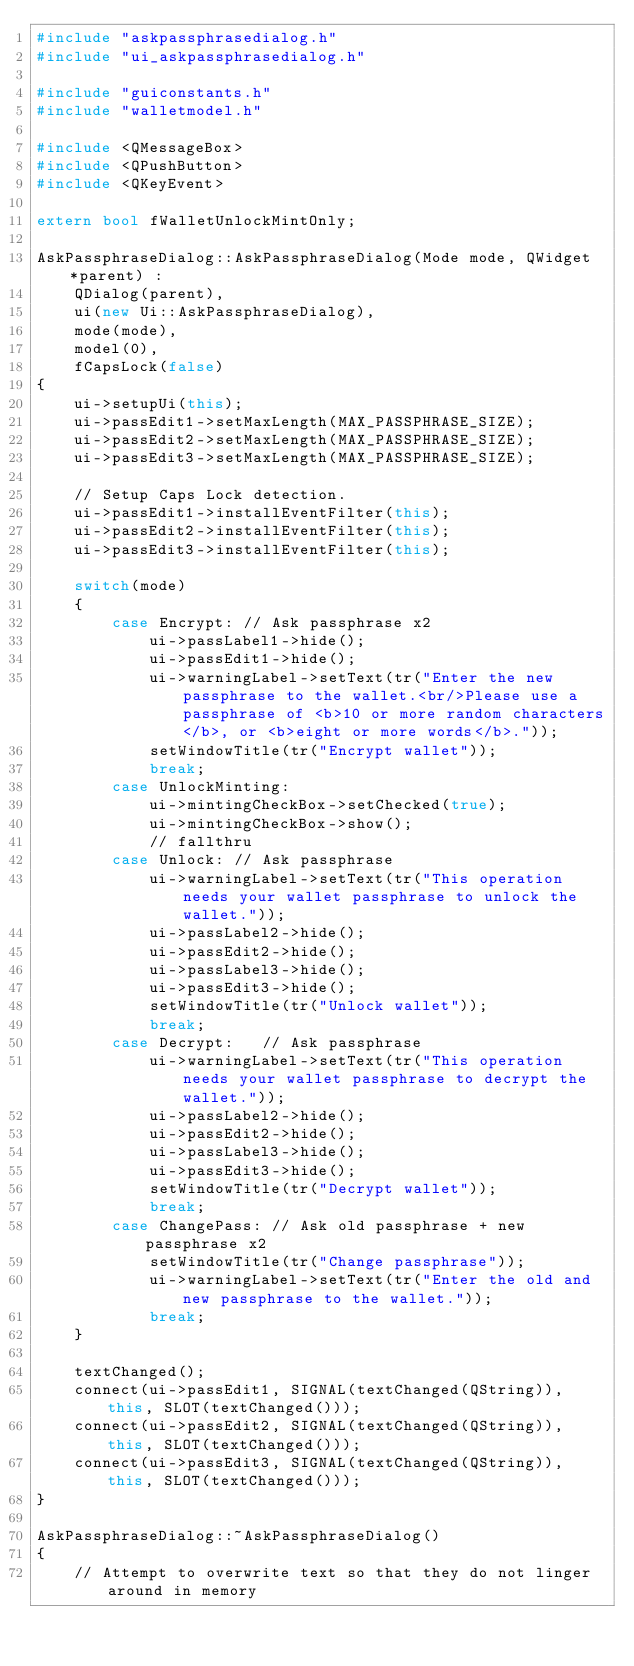Convert code to text. <code><loc_0><loc_0><loc_500><loc_500><_C++_>#include "askpassphrasedialog.h"
#include "ui_askpassphrasedialog.h"

#include "guiconstants.h"
#include "walletmodel.h"

#include <QMessageBox>
#include <QPushButton>
#include <QKeyEvent>

extern bool fWalletUnlockMintOnly;

AskPassphraseDialog::AskPassphraseDialog(Mode mode, QWidget *parent) :
    QDialog(parent),
    ui(new Ui::AskPassphraseDialog),
    mode(mode),
    model(0),
    fCapsLock(false)
{
    ui->setupUi(this);
    ui->passEdit1->setMaxLength(MAX_PASSPHRASE_SIZE);
    ui->passEdit2->setMaxLength(MAX_PASSPHRASE_SIZE);
    ui->passEdit3->setMaxLength(MAX_PASSPHRASE_SIZE);
    
    // Setup Caps Lock detection.
    ui->passEdit1->installEventFilter(this);
    ui->passEdit2->installEventFilter(this);
    ui->passEdit3->installEventFilter(this);

    switch(mode)
    {
        case Encrypt: // Ask passphrase x2
            ui->passLabel1->hide();
            ui->passEdit1->hide();
            ui->warningLabel->setText(tr("Enter the new passphrase to the wallet.<br/>Please use a passphrase of <b>10 or more random characters</b>, or <b>eight or more words</b>."));
            setWindowTitle(tr("Encrypt wallet"));
            break;
        case UnlockMinting:
            ui->mintingCheckBox->setChecked(true);
            ui->mintingCheckBox->show();
            // fallthru
        case Unlock: // Ask passphrase
            ui->warningLabel->setText(tr("This operation needs your wallet passphrase to unlock the wallet."));
            ui->passLabel2->hide();
            ui->passEdit2->hide();
            ui->passLabel3->hide();
            ui->passEdit3->hide();
            setWindowTitle(tr("Unlock wallet"));
            break;
        case Decrypt:   // Ask passphrase
            ui->warningLabel->setText(tr("This operation needs your wallet passphrase to decrypt the wallet."));
            ui->passLabel2->hide();
            ui->passEdit2->hide();
            ui->passLabel3->hide();
            ui->passEdit3->hide();
            setWindowTitle(tr("Decrypt wallet"));
            break;
        case ChangePass: // Ask old passphrase + new passphrase x2
            setWindowTitle(tr("Change passphrase"));
            ui->warningLabel->setText(tr("Enter the old and new passphrase to the wallet."));
            break;
    }

    textChanged();
    connect(ui->passEdit1, SIGNAL(textChanged(QString)), this, SLOT(textChanged()));
    connect(ui->passEdit2, SIGNAL(textChanged(QString)), this, SLOT(textChanged()));
    connect(ui->passEdit3, SIGNAL(textChanged(QString)), this, SLOT(textChanged()));
}

AskPassphraseDialog::~AskPassphraseDialog()
{
    // Attempt to overwrite text so that they do not linger around in memory</code> 